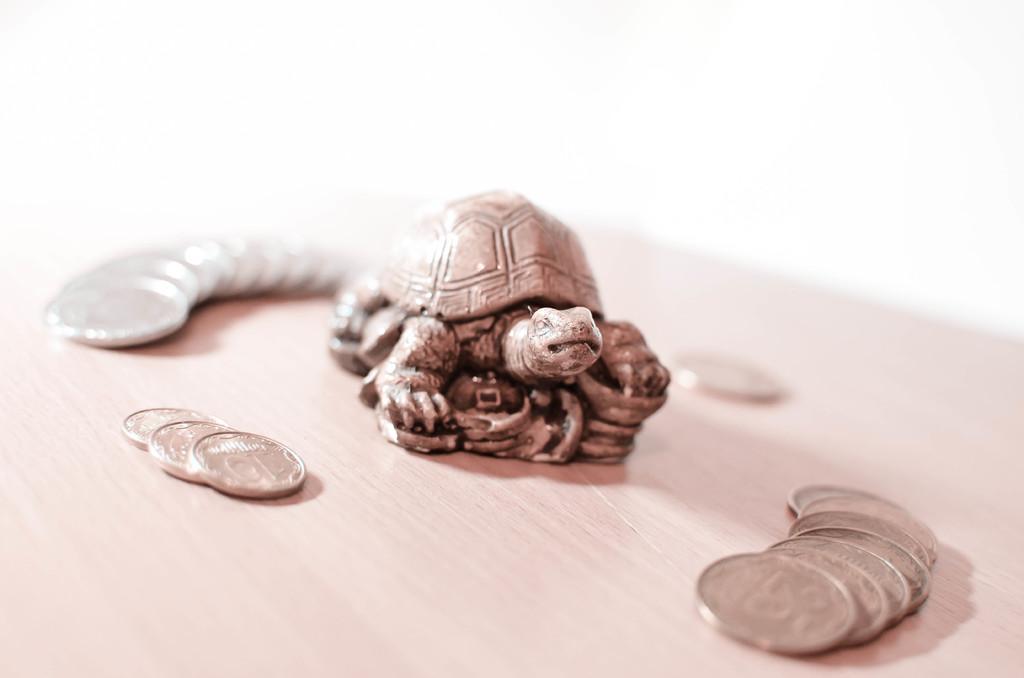Could you give a brief overview of what you see in this image? In this image we can see a decor tortoise and coins on the table. 